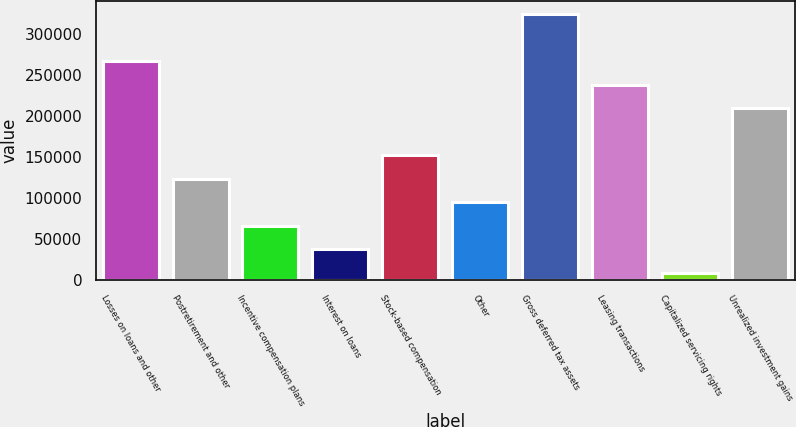Convert chart to OTSL. <chart><loc_0><loc_0><loc_500><loc_500><bar_chart><fcel>Losses on loans and other<fcel>Postretirement and other<fcel>Incentive compensation plans<fcel>Interest on loans<fcel>Stock-based compensation<fcel>Other<fcel>Gross deferred tax assets<fcel>Leasing transactions<fcel>Capitalized servicing rights<fcel>Unrealized investment gains<nl><fcel>266356<fcel>123288<fcel>66061<fcel>37447.5<fcel>151902<fcel>94674.5<fcel>323582<fcel>237742<fcel>8834<fcel>209128<nl></chart> 